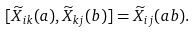<formula> <loc_0><loc_0><loc_500><loc_500>[ \widetilde { X } _ { i k } ( a ) , \widetilde { X } _ { k j } ( b ) ] = \widetilde { X } _ { i j } ( a b ) .</formula> 